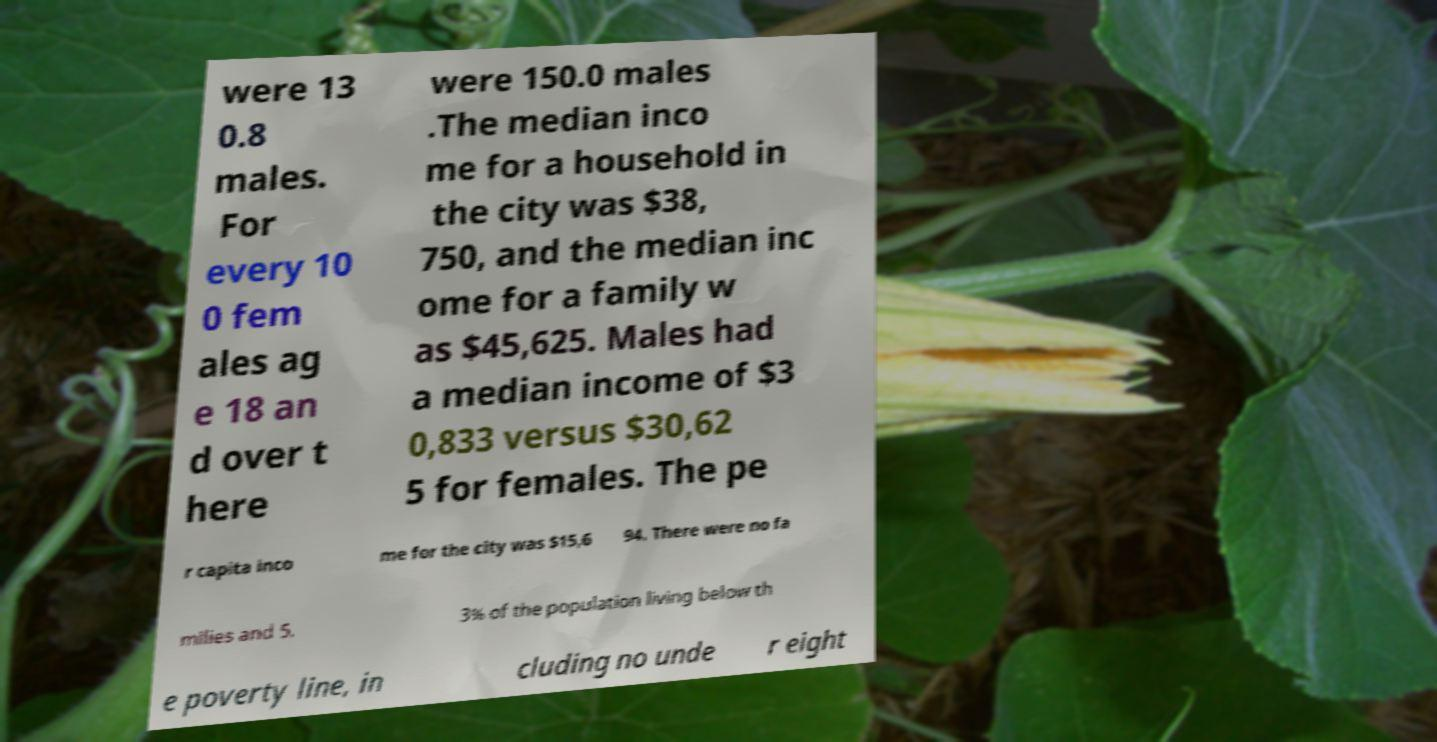Can you read and provide the text displayed in the image?This photo seems to have some interesting text. Can you extract and type it out for me? were 13 0.8 males. For every 10 0 fem ales ag e 18 an d over t here were 150.0 males .The median inco me for a household in the city was $38, 750, and the median inc ome for a family w as $45,625. Males had a median income of $3 0,833 versus $30,62 5 for females. The pe r capita inco me for the city was $15,6 94. There were no fa milies and 5. 3% of the population living below th e poverty line, in cluding no unde r eight 